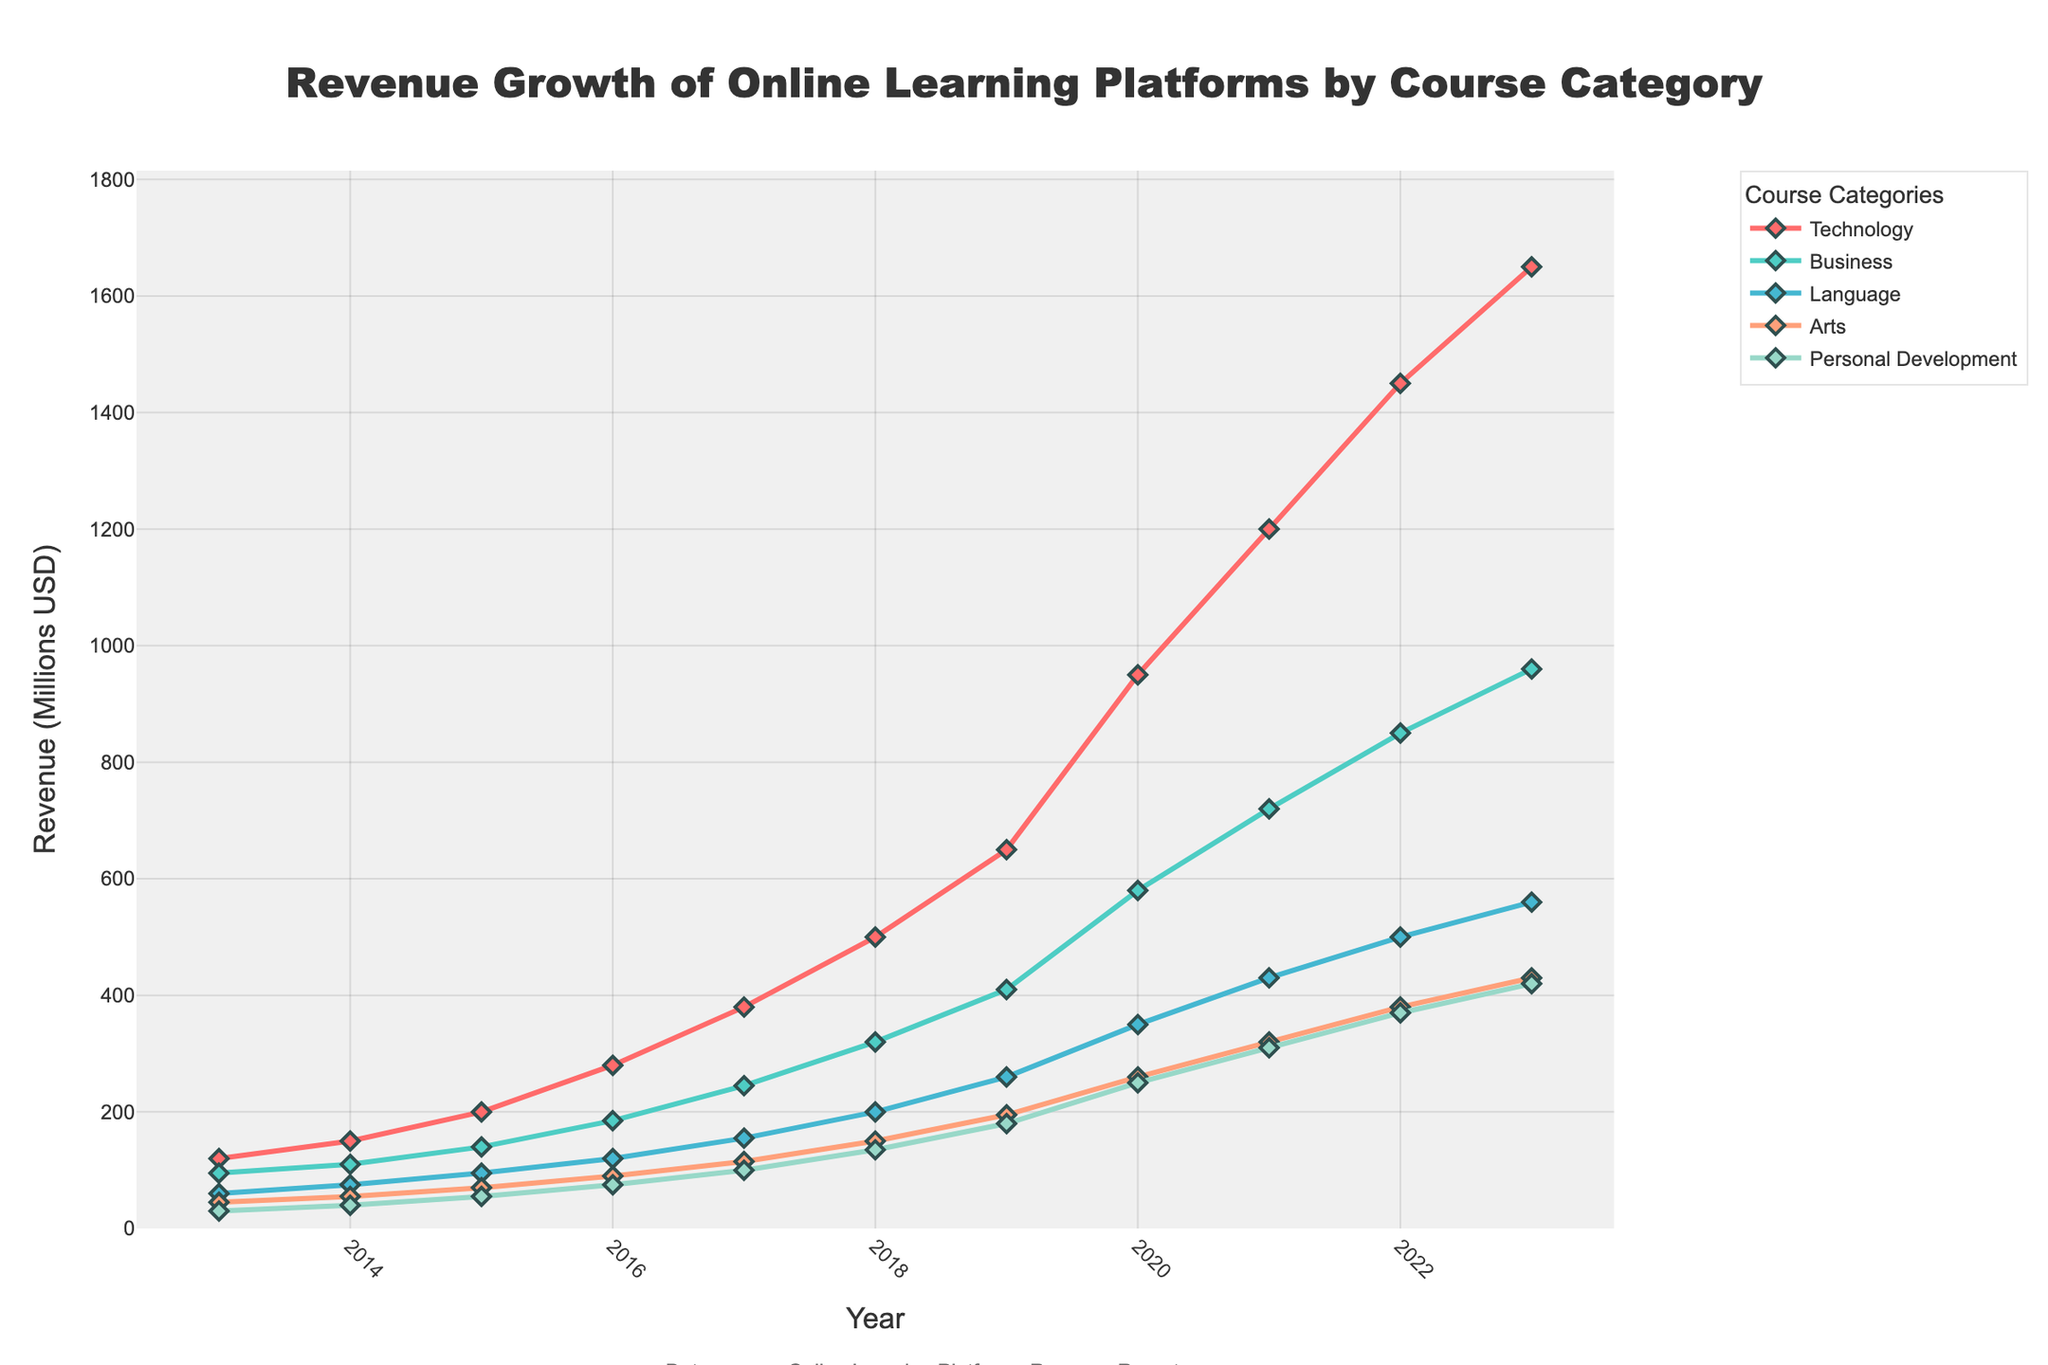What was the revenue for the Technology category in 2020? Look at the line corresponding to the Technology category and find its value at the year 2020.
Answer: 950 Which course category had the highest revenue growth from 2019 to 2020? Compare the revenue values for each category between 2019 and 2020 and identify the one with the largest increase.
Answer: Technology Did any category have a decline in revenue over the analyzed period? Check the overall trend lines for each category to see if any have a downward slope at any point.
Answer: No In which year did the Business category first exceed 700 million USD in revenue? Follow the Business category line and identify the year when it first crosses the 700 million USD mark.
Answer: 2021 How much higher was the revenue for the Technology category than for Personal Development in 2023? Look at the revenue values for both Technology and Personal Development categories in 2023 and subtract the latter from the former.
Answer: 1230 What is the average revenue growth per year for the Language category between 2015 and 2020? Calculate the difference in revenue for Language between 2015 and 2020 and divide by the number of years (2020-2015).
Answer: 51 Which year saw the largest single-year revenue jump across all categories? Compare the year-over-year changes for all categories and identify the year with the highest single-year increase.
Answer: 2020 For how many years did the revenue for the Arts category remain below 100 million USD? Check the revenue figures for the Arts category and count the number of years it stayed below 100 million USD.
Answer: 4 Compare the revenue of Business and Personal Development categories in 2018. Which was higher, and by how much? Find the revenue values for both categories in 2018, identify the higher one, and calculate the difference.
Answer: Business, 185 What is the cumulative revenue for the Technology category from 2013 to 2023? Sum up the revenue figures for the Technology category across all the years from 2013 to 2023.
Answer: 8330 